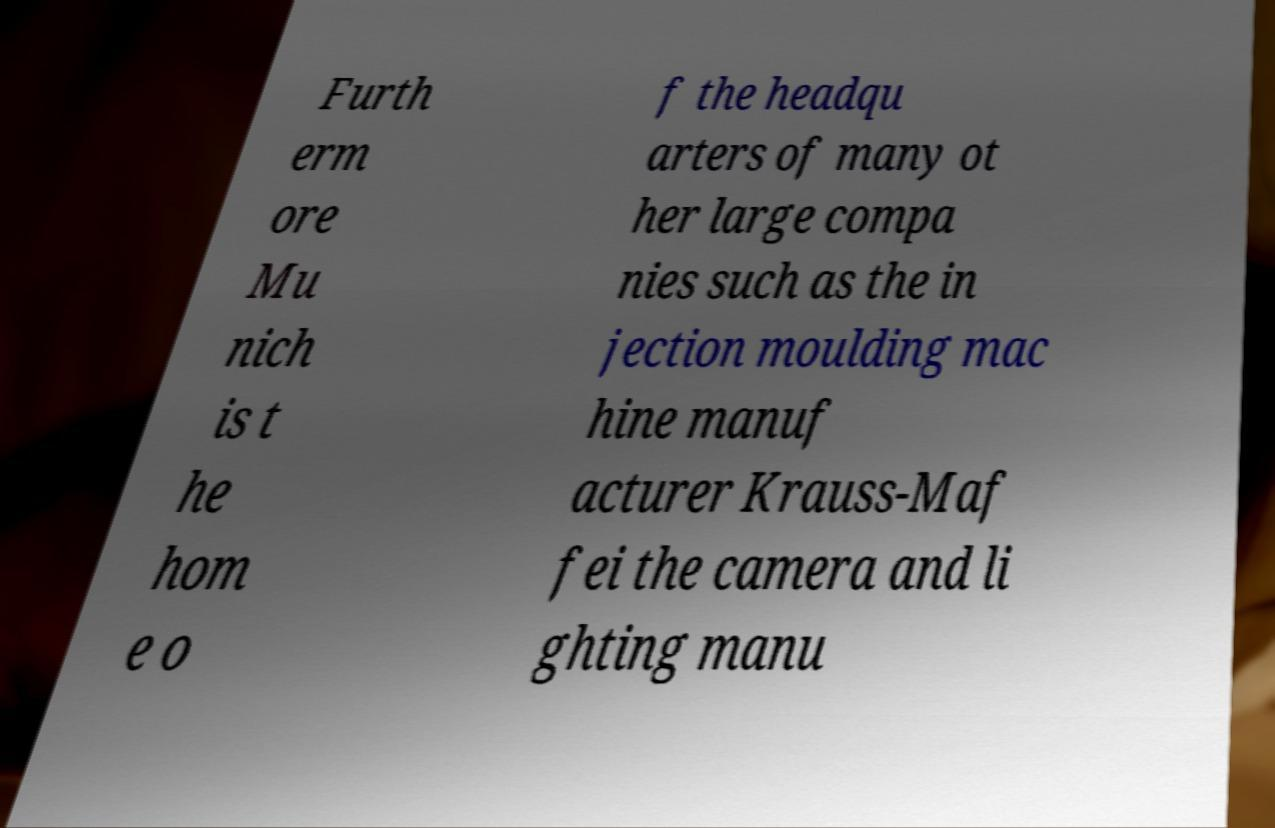Could you assist in decoding the text presented in this image and type it out clearly? Furth erm ore Mu nich is t he hom e o f the headqu arters of many ot her large compa nies such as the in jection moulding mac hine manuf acturer Krauss-Maf fei the camera and li ghting manu 